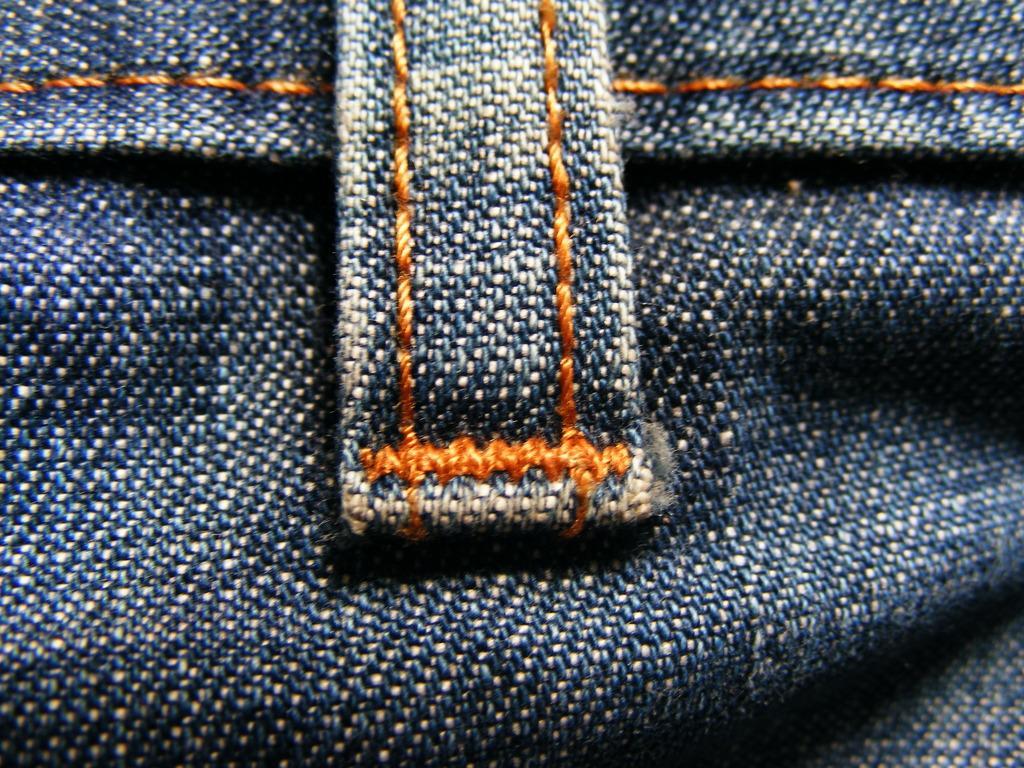How would you summarize this image in a sentence or two? In this image we can see jeans cloth. 